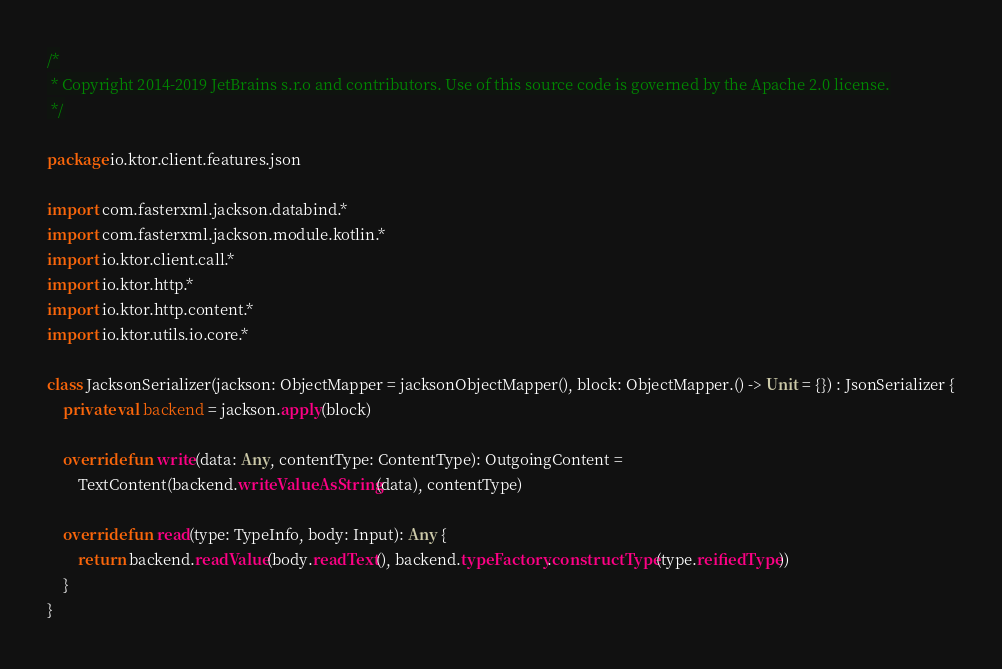<code> <loc_0><loc_0><loc_500><loc_500><_Kotlin_>/*
 * Copyright 2014-2019 JetBrains s.r.o and contributors. Use of this source code is governed by the Apache 2.0 license.
 */

package io.ktor.client.features.json

import com.fasterxml.jackson.databind.*
import com.fasterxml.jackson.module.kotlin.*
import io.ktor.client.call.*
import io.ktor.http.*
import io.ktor.http.content.*
import io.ktor.utils.io.core.*

class JacksonSerializer(jackson: ObjectMapper = jacksonObjectMapper(), block: ObjectMapper.() -> Unit = {}) : JsonSerializer {
    private val backend = jackson.apply(block)

    override fun write(data: Any, contentType: ContentType): OutgoingContent =
        TextContent(backend.writeValueAsString(data), contentType)

    override fun read(type: TypeInfo, body: Input): Any {
        return backend.readValue(body.readText(), backend.typeFactory.constructType(type.reifiedType))
    }
}
</code> 